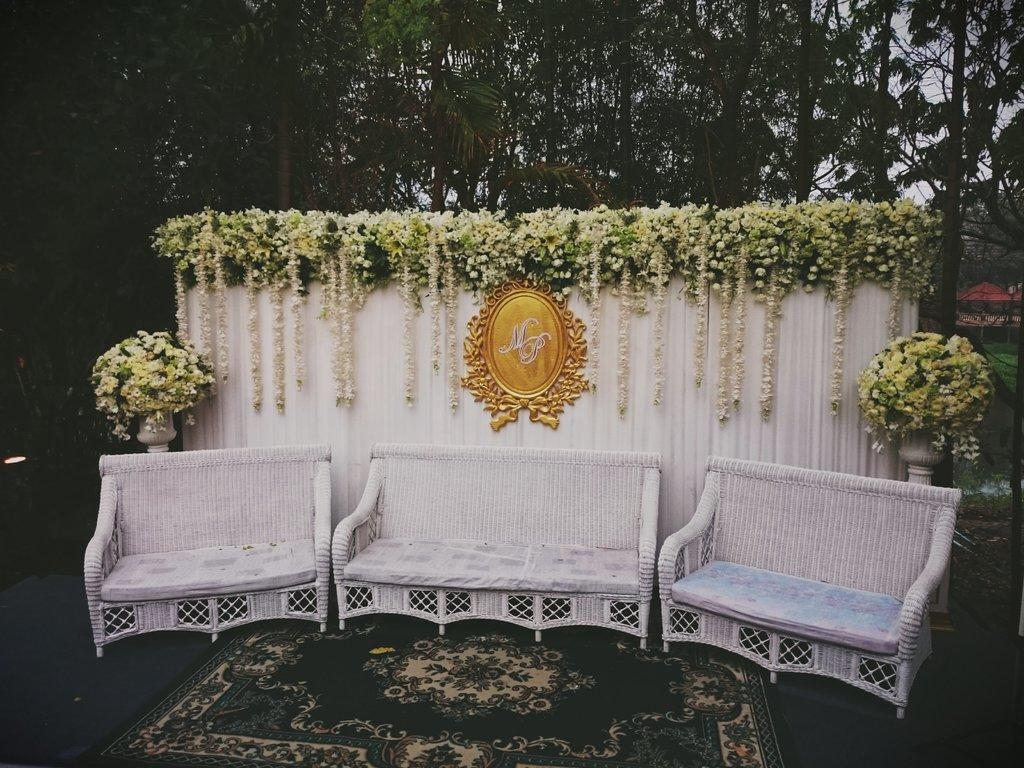How many sofa sets are arranged in the image? There are three sofa sets arranged in the image. What is present below the sofa sets? A carpet is present below the sofa sets. What decorative items can be seen in the image? There are garlands and flowers with leaves in the image. Where are the flowers and leaves located? The flowers and leaves are on a white screen. How are the flowers and leaves arranged in the image? There are two bouquets on either side of the sofa sets. What type of salt is sprinkled on the carpet in the image? There is no salt present in the image; it features sofa sets, a carpet, garlands, flowers, leaves, and bouquets. What kind of chain can be seen connecting the sofa sets in the image? There is no chain connecting the sofa sets in the image. 